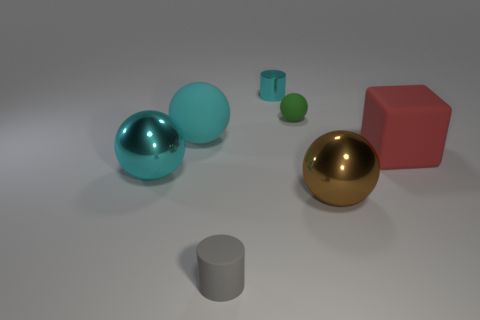Is the number of brown objects that are left of the brown ball greater than the number of cyan rubber things behind the small cyan metallic cylinder?
Your answer should be very brief. No. Is there a gray object of the same shape as the red matte object?
Give a very brief answer. No. There is a sphere on the left side of the big thing that is behind the cube; what is its size?
Ensure brevity in your answer.  Large. The cyan shiny thing right of the large cyan ball that is behind the shiny ball on the left side of the green rubber sphere is what shape?
Your answer should be very brief. Cylinder. There is a cyan sphere that is made of the same material as the tiny gray cylinder; what is its size?
Offer a terse response. Large. Is the number of large spheres greater than the number of small blue matte cubes?
Give a very brief answer. Yes. What is the material of the red cube that is the same size as the brown sphere?
Your answer should be compact. Rubber. Do the cylinder in front of the cyan cylinder and the cyan metal ball have the same size?
Provide a succinct answer. No. How many blocks are either large cyan shiny things or red rubber objects?
Offer a very short reply. 1. There is a tiny gray object that is in front of the green rubber sphere; what is it made of?
Offer a terse response. Rubber. 